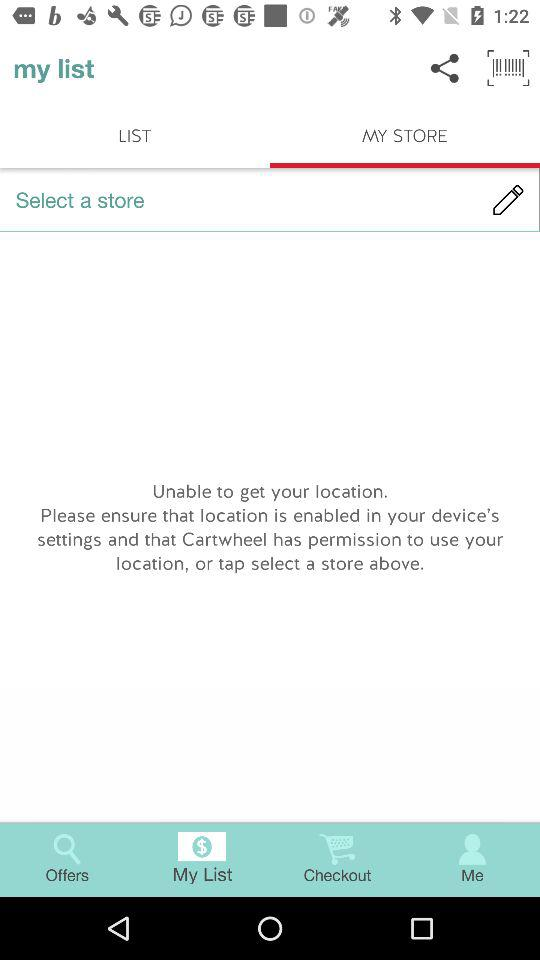What is the name of the application? The name of the application is "my list". 